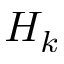<formula> <loc_0><loc_0><loc_500><loc_500>H _ { k }</formula> 